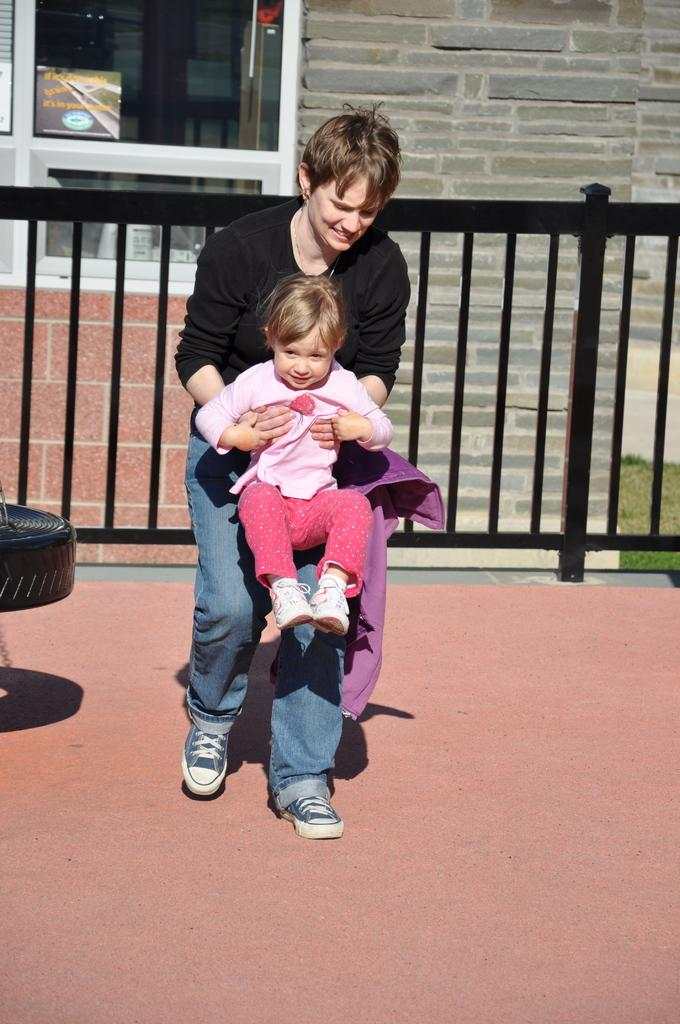Who is the main subject in the image? There is a lady in the image. What is the lady doing in the image? The lady is holding a baby in her hands in her hands. What can be seen behind the lady? There is fencing behind the lady. What is behind the fencing? There is a wall with a glass window behind the fencing. What idea does the boy have while looking at the mountain in the image? There is no boy or mountain present in the image. 